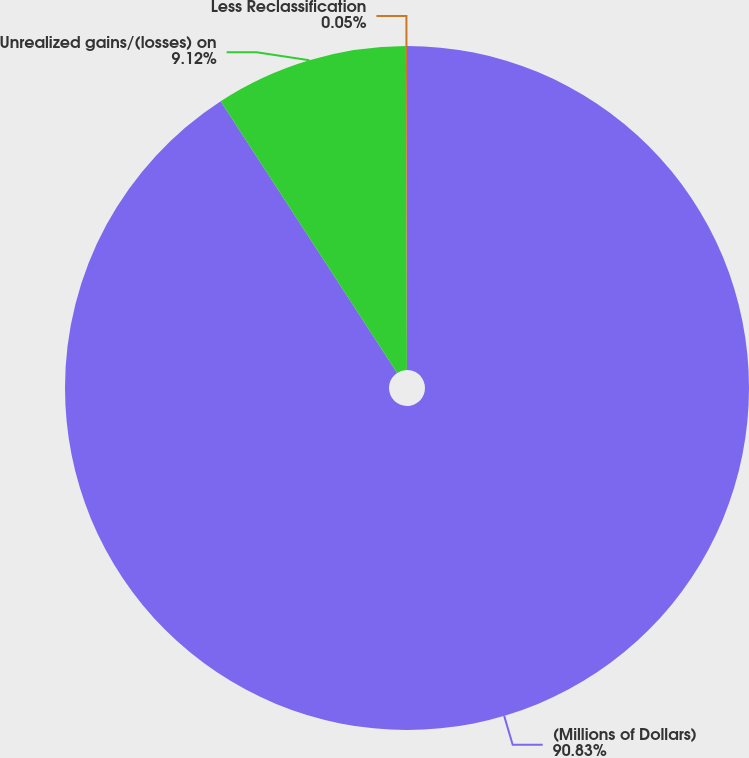Convert chart. <chart><loc_0><loc_0><loc_500><loc_500><pie_chart><fcel>(Millions of Dollars)<fcel>Unrealized gains/(losses) on<fcel>Less Reclassification<nl><fcel>90.83%<fcel>9.12%<fcel>0.05%<nl></chart> 